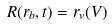<formula> <loc_0><loc_0><loc_500><loc_500>R ( r _ { b } , t ) = r _ { v } ( V )</formula> 